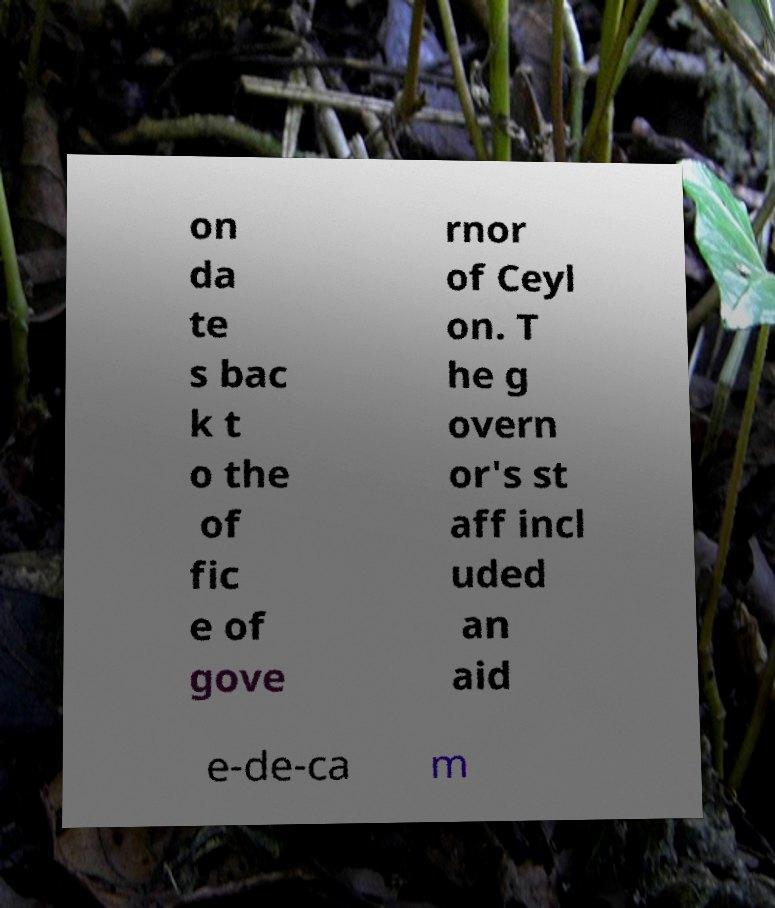Please identify and transcribe the text found in this image. on da te s bac k t o the of fic e of gove rnor of Ceyl on. T he g overn or's st aff incl uded an aid e-de-ca m 